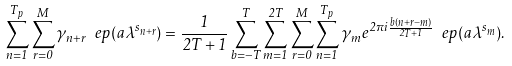Convert formula to latex. <formula><loc_0><loc_0><loc_500><loc_500>\sum _ { n = 1 } ^ { T _ { p } } \sum _ { r = 0 } ^ { M } \gamma _ { n + r } \ e p ( a \lambda ^ { s _ { n + r } } ) = \frac { 1 } { 2 T + 1 } \sum _ { b = - T } ^ { T } \sum _ { m = 1 } ^ { 2 T } \sum _ { r = 0 } ^ { M } \sum _ { n = 1 } ^ { T _ { p } } \gamma _ { m } e ^ { 2 \pi i \frac { b ( n + r - m ) } { 2 T + 1 } } \ e p ( a \lambda ^ { s _ { m } } ) .</formula> 